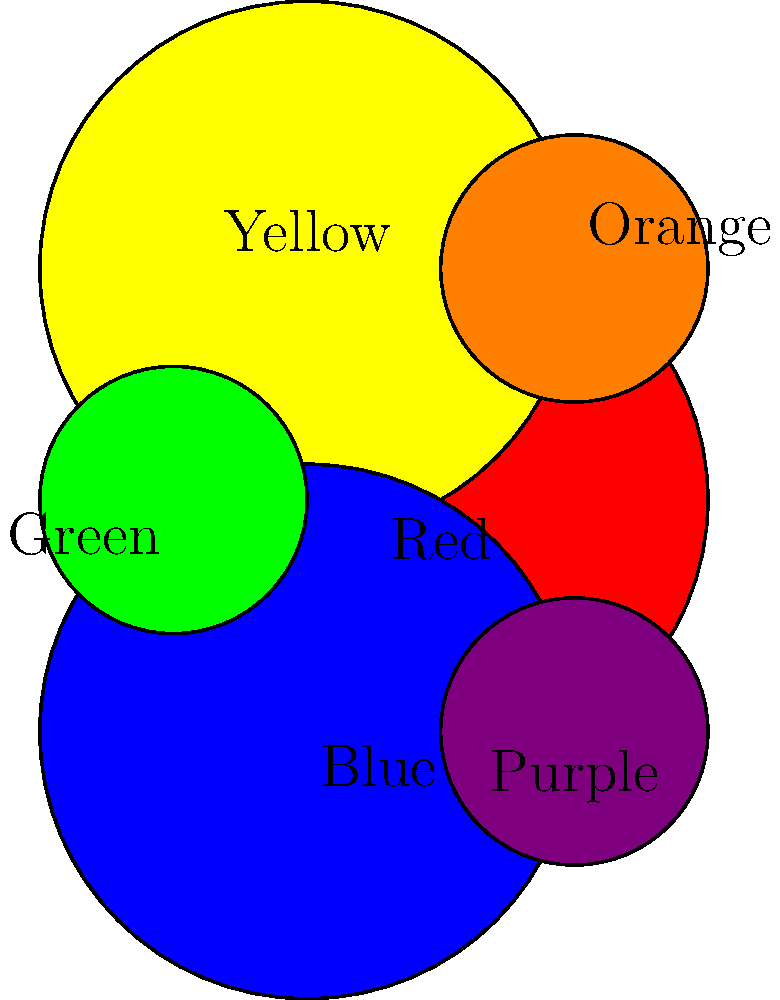In the color wheel shown above, which two primary colors would you mix to create the secondary color Orange? Explain your reasoning based on color theory principles. To determine which primary colors create Orange, we need to follow these steps:

1. Identify the primary colors: In the color wheel, the primary colors are Red, Yellow, and Blue.

2. Locate Orange: Orange is positioned between Red and Yellow in the color wheel.

3. Apply color mixing principles:
   a) Secondary colors are created by mixing two primary colors.
   b) The secondary color is always located between the two primary colors that create it.

4. Analyze Orange's position:
   Orange is situated between Red and Yellow, indicating that these are the two primary colors that create it.

5. Confirm with color theory:
   In color theory, Orange is indeed created by mixing Red and Yellow pigments.

Therefore, based on the color wheel and color theory principles, we can conclude that Red and Yellow are the two primary colors that create Orange.
Answer: Red and Yellow 